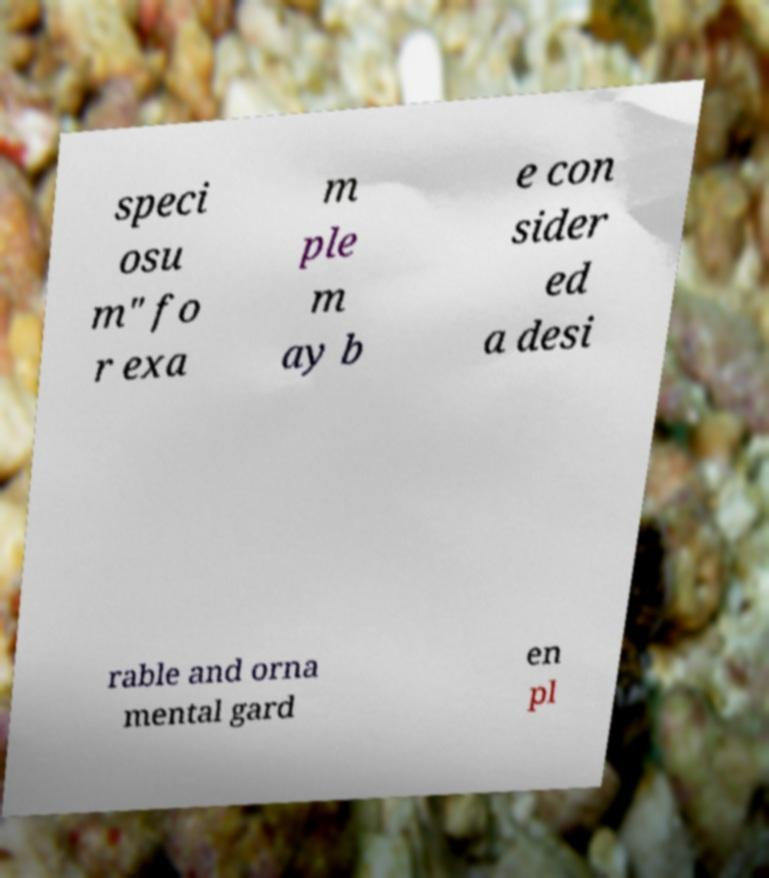I need the written content from this picture converted into text. Can you do that? speci osu m" fo r exa m ple m ay b e con sider ed a desi rable and orna mental gard en pl 